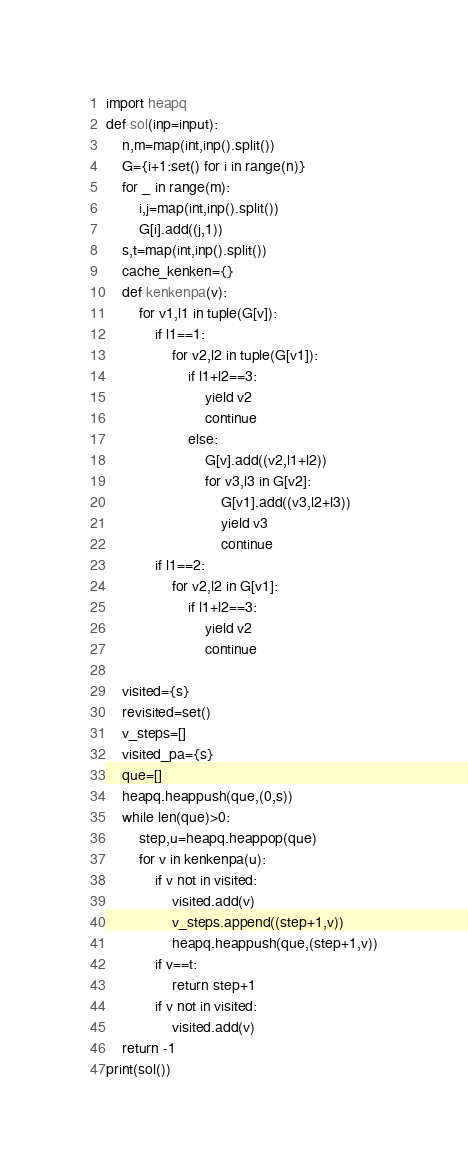Convert code to text. <code><loc_0><loc_0><loc_500><loc_500><_Python_>import heapq
def sol(inp=input):
    n,m=map(int,inp().split())
    G={i+1:set() for i in range(n)}
    for _ in range(m):
        i,j=map(int,inp().split())
        G[i].add((j,1))
    s,t=map(int,inp().split())
    cache_kenken={}
    def kenkenpa(v):
        for v1,l1 in tuple(G[v]):
            if l1==1:
                for v2,l2 in tuple(G[v1]):
                    if l1+l2==3:
                        yield v2
                        continue
                    else:
                        G[v].add((v2,l1+l2))
                        for v3,l3 in G[v2]:
                            G[v1].add((v3,l2+l3))
                            yield v3
                            continue
            if l1==2:
                for v2,l2 in G[v1]:
                    if l1+l2==3:
                        yield v2
                        continue
        
    visited={s}
    revisited=set()
    v_steps=[]
    visited_pa={s}
    que=[]
    heapq.heappush(que,(0,s))
    while len(que)>0:
        step,u=heapq.heappop(que)
        for v in kenkenpa(u):
            if v not in visited:
                visited.add(v)
                v_steps.append((step+1,v))
                heapq.heappush(que,(step+1,v))
            if v==t:
                return step+1
            if v not in visited:
                visited.add(v)
    return -1
print(sol())</code> 